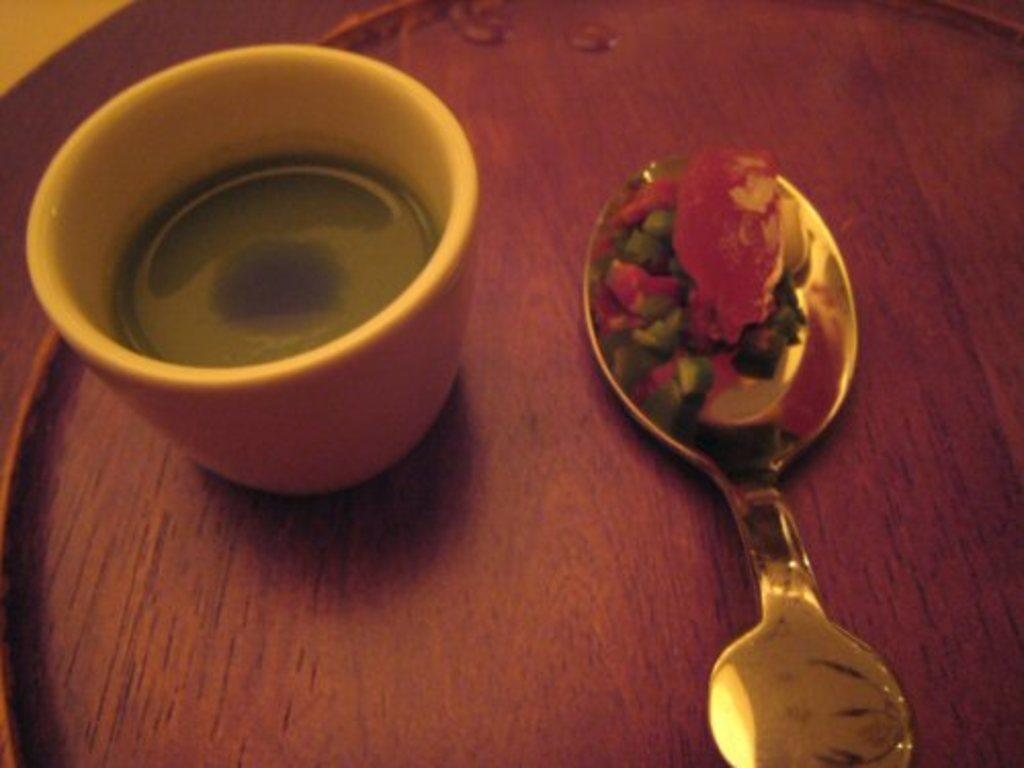In one or two sentences, can you explain what this image depicts? There is a cup and a spoon on a wooden surface, it seems like some food items on the spoon. 